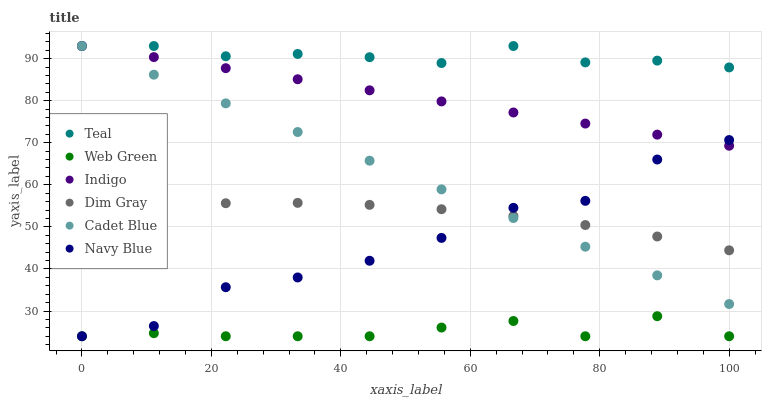Does Web Green have the minimum area under the curve?
Answer yes or no. Yes. Does Teal have the maximum area under the curve?
Answer yes or no. Yes. Does Indigo have the minimum area under the curve?
Answer yes or no. No. Does Indigo have the maximum area under the curve?
Answer yes or no. No. Is Cadet Blue the smoothest?
Answer yes or no. Yes. Is Navy Blue the roughest?
Answer yes or no. Yes. Is Indigo the smoothest?
Answer yes or no. No. Is Indigo the roughest?
Answer yes or no. No. Does Navy Blue have the lowest value?
Answer yes or no. Yes. Does Indigo have the lowest value?
Answer yes or no. No. Does Teal have the highest value?
Answer yes or no. Yes. Does Navy Blue have the highest value?
Answer yes or no. No. Is Web Green less than Indigo?
Answer yes or no. Yes. Is Teal greater than Web Green?
Answer yes or no. Yes. Does Cadet Blue intersect Dim Gray?
Answer yes or no. Yes. Is Cadet Blue less than Dim Gray?
Answer yes or no. No. Is Cadet Blue greater than Dim Gray?
Answer yes or no. No. Does Web Green intersect Indigo?
Answer yes or no. No. 